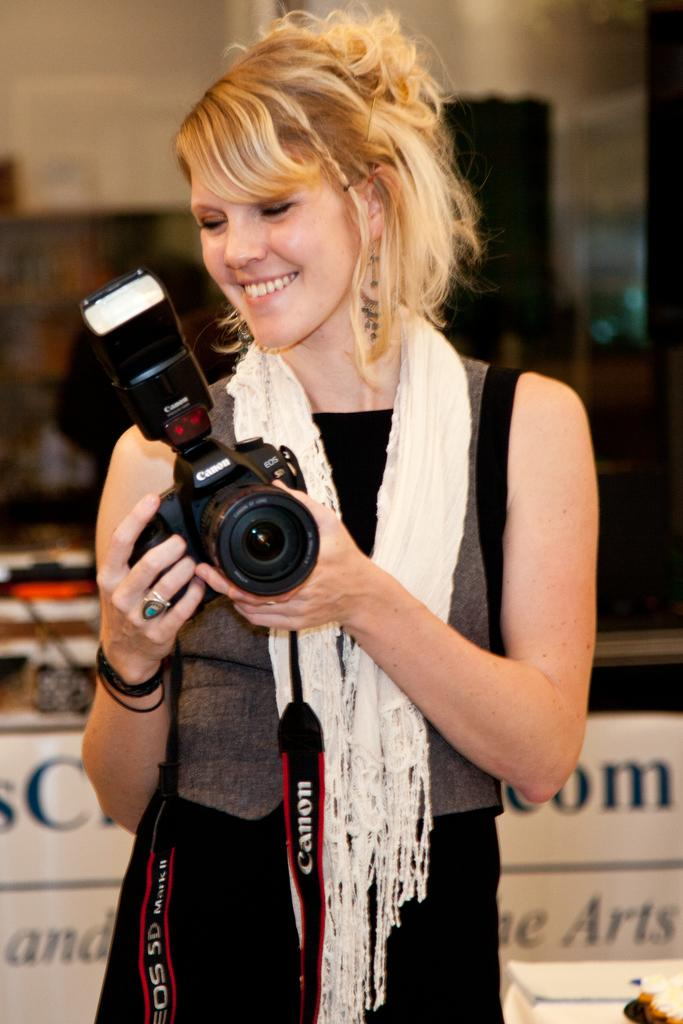Who is present in the image? There is a woman in the image. What is the woman doing in the image? The woman is standing and smiling in the image. What is the woman holding in the image? The woman is holding a camera in the image. What can be seen in the background of the image? There is a wooden cupboard and a wall in the background of the image. What type of bottle is visible on the wall in the image? There is no bottle visible on the wall in the image. 